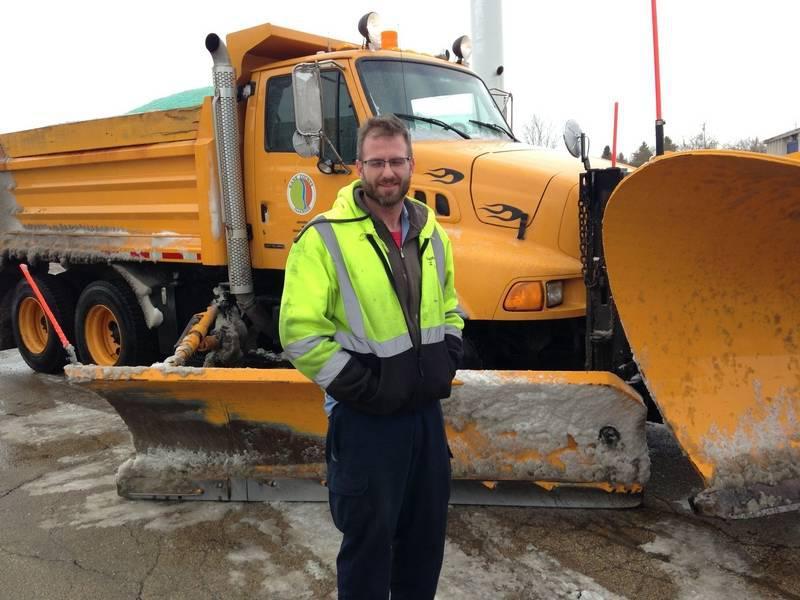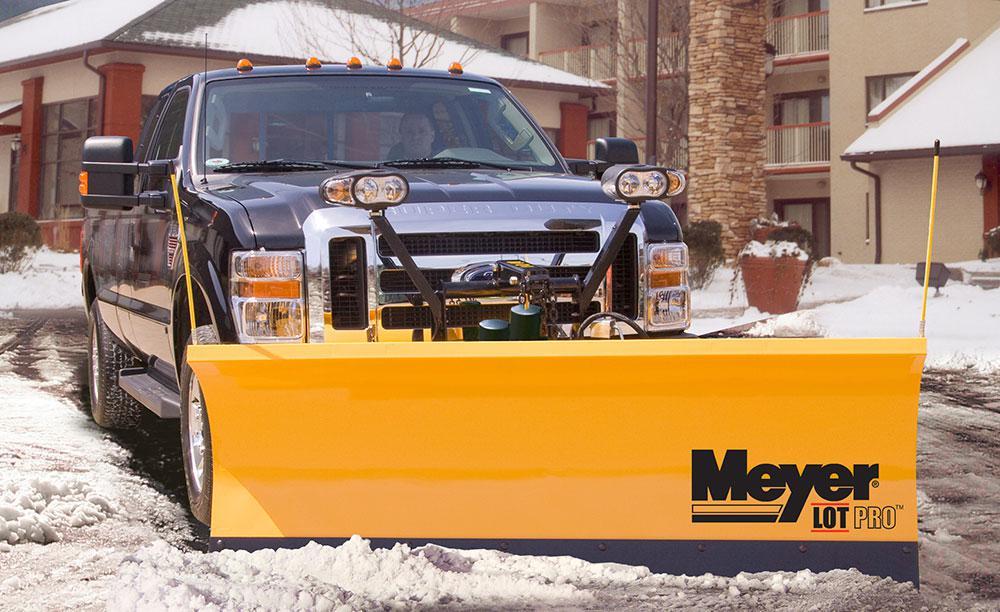The first image is the image on the left, the second image is the image on the right. Evaluate the accuracy of this statement regarding the images: "A person is standing near a yellow heavy duty truck.". Is it true? Answer yes or no. Yes. The first image is the image on the left, the second image is the image on the right. Considering the images on both sides, is "In one image, on a snowy street, a yellow snow blade is attached to a dark truck with extra headlights." valid? Answer yes or no. Yes. 